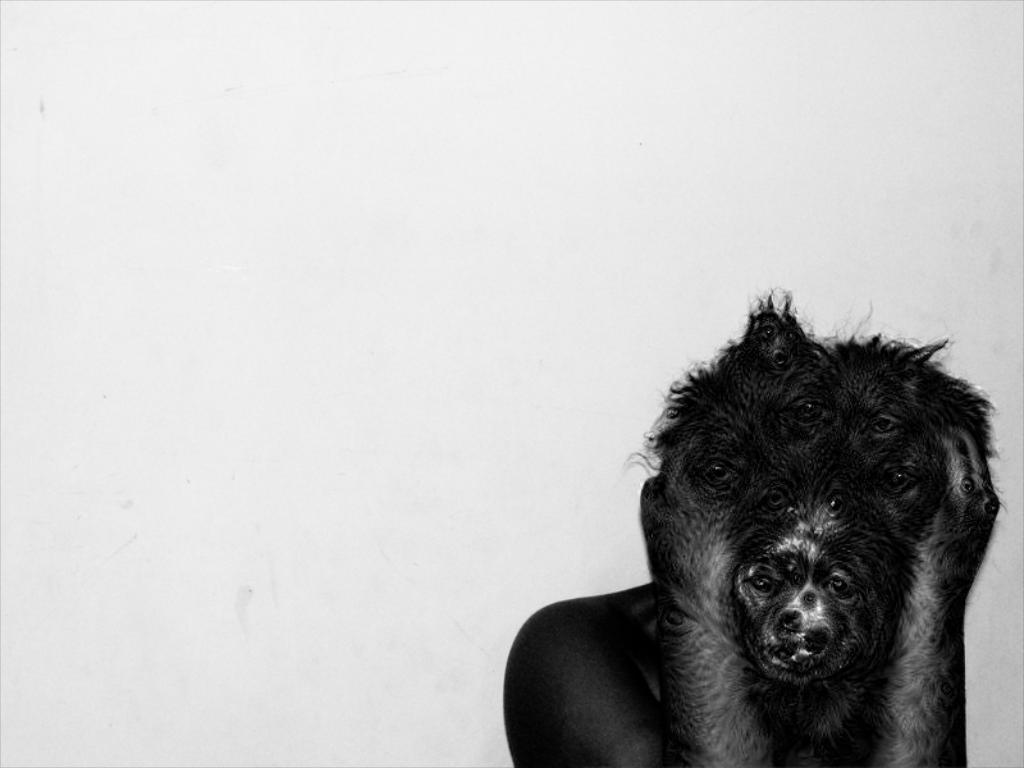Who or what is the main subject of the image? There is a person in the image. What is the person wearing on their face? The person is wearing an animal mask. What can be seen behind the person in the image? There is a plain wall in the background of the image. What historical event is being commemorated by the person wearing the zebra mask in the image? There is no zebra mask present in the image, and no historical event is being commemorated. 